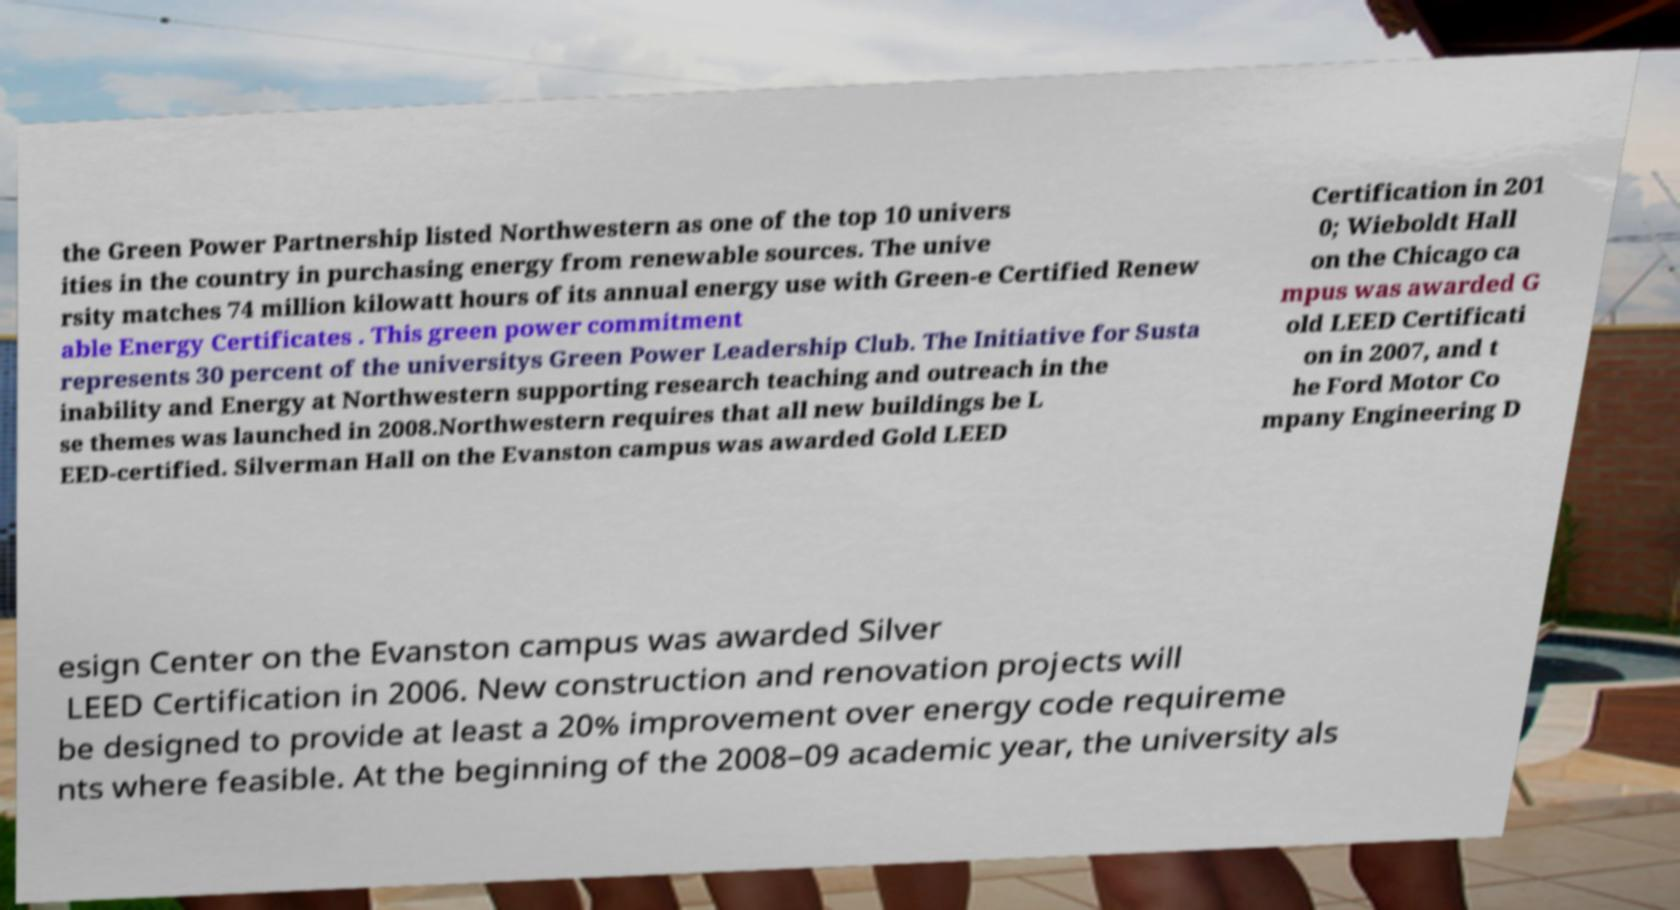What messages or text are displayed in this image? I need them in a readable, typed format. the Green Power Partnership listed Northwestern as one of the top 10 univers ities in the country in purchasing energy from renewable sources. The unive rsity matches 74 million kilowatt hours of its annual energy use with Green-e Certified Renew able Energy Certificates . This green power commitment represents 30 percent of the universitys Green Power Leadership Club. The Initiative for Susta inability and Energy at Northwestern supporting research teaching and outreach in the se themes was launched in 2008.Northwestern requires that all new buildings be L EED-certified. Silverman Hall on the Evanston campus was awarded Gold LEED Certification in 201 0; Wieboldt Hall on the Chicago ca mpus was awarded G old LEED Certificati on in 2007, and t he Ford Motor Co mpany Engineering D esign Center on the Evanston campus was awarded Silver LEED Certification in 2006. New construction and renovation projects will be designed to provide at least a 20% improvement over energy code requireme nts where feasible. At the beginning of the 2008–09 academic year, the university als 